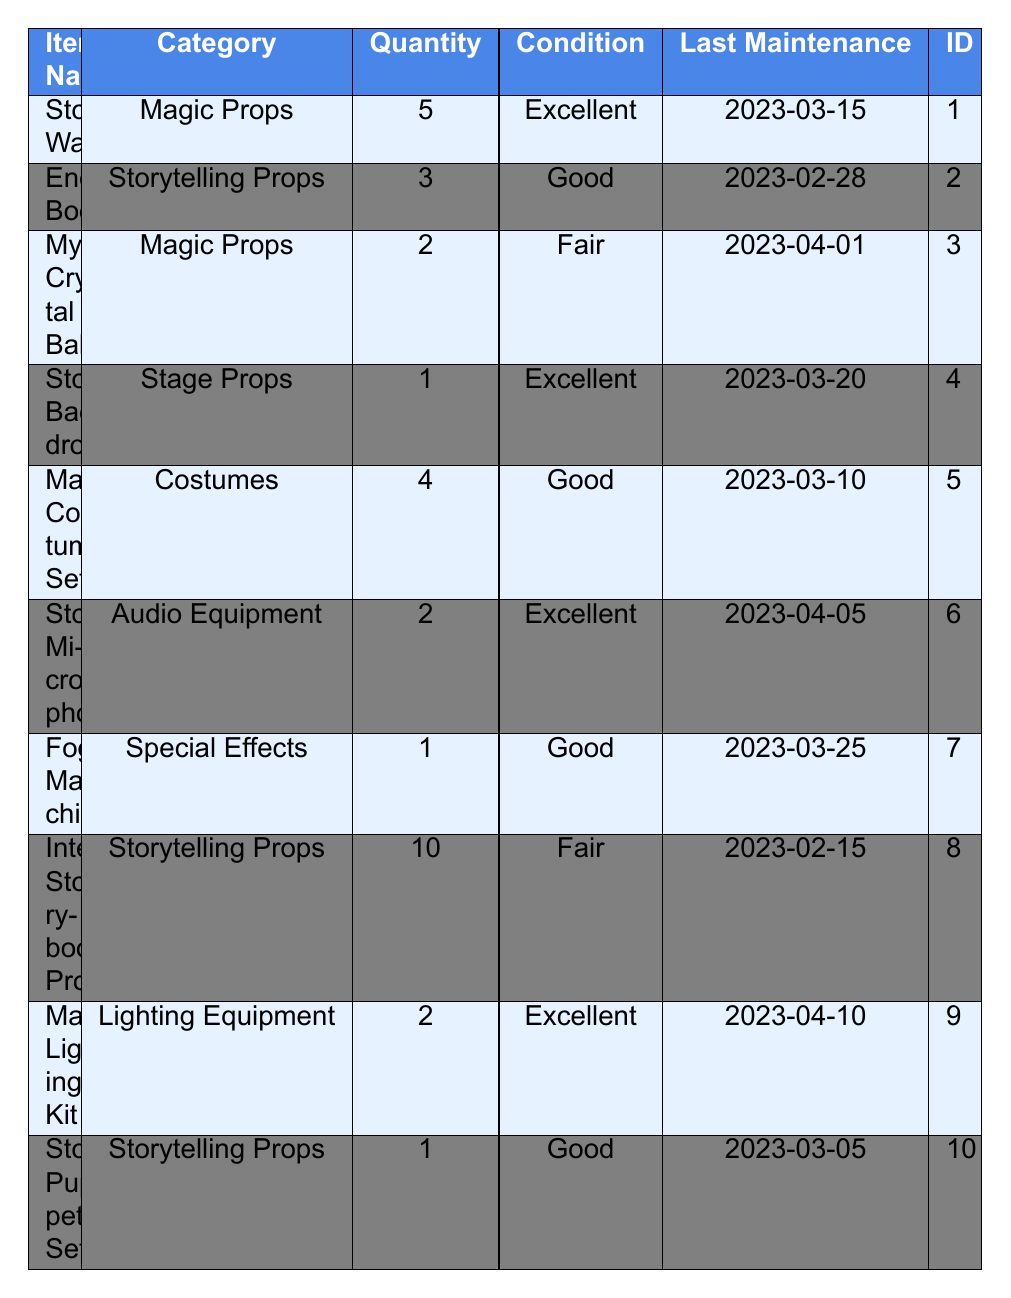What is the quantity of the "Storytelling Wand"? The table indicates that there are 5 units of the "Storytelling Wand" available in the inventory.
Answer: 5 How many types of "Storytelling Props" are listed in the inventory? There are 3 items categorized as "Storytelling Props": "Enchanted Book," "Interactive Storybook Props," and "Storytelling Puppet Set."
Answer: 3 Which prop has the highest quantity? The "Interactive Storybook Props" has the highest quantity with 10 units available.
Answer: Interactive Storybook Props What is the condition of the "Fog Machine"? The table lists "Fog Machine" as being in "Good" condition.
Answer: Good How many total "Magic Props" are available? There are 5 "Storytelling Wand" and 2 "Mystical Crystal Ball," resulting in a total of 7 "Magic Props."
Answer: 7 Is there any item categorized as "Costumes"? Yes, there is one item named "Magical Costume Set" in the "Costumes" category.
Answer: Yes How many items have been maintained after March 15, 2023? The items that were maintained after March 15, 2023, are "Mystical Crystal Ball," "Storyteller's Microphone," "Magical Lighting Kit," and "Fog Machine," totaling 4 items.
Answer: 4 Which props are in "Fair" condition? The "Mystical Crystal Ball" and "Interactive Storybook Props" are both listed as being in "Fair" condition.
Answer: Mystical Crystal Ball, Interactive Storybook Props What is the average quantity of "Stage Props"? There is 1 "Storybook Backdrop" under "Stage Props," thus the average quantity is 1.
Answer: 1 Are there more "Audio Equipment" items than "Special Effects" items? Yes, there are 2 "Audio Equipment" items while only 1 "Special Effects" item is listed.
Answer: Yes 